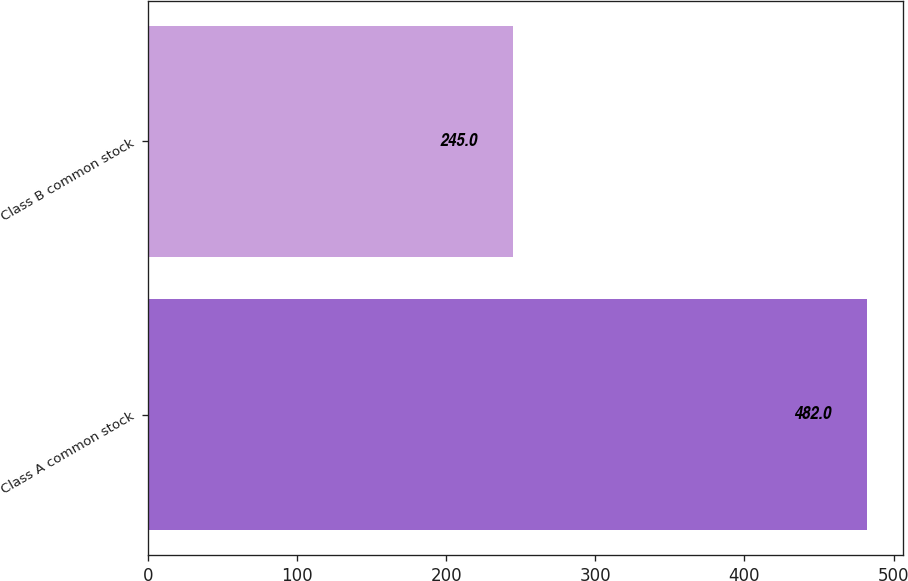Convert chart. <chart><loc_0><loc_0><loc_500><loc_500><bar_chart><fcel>Class A common stock<fcel>Class B common stock<nl><fcel>482<fcel>245<nl></chart> 